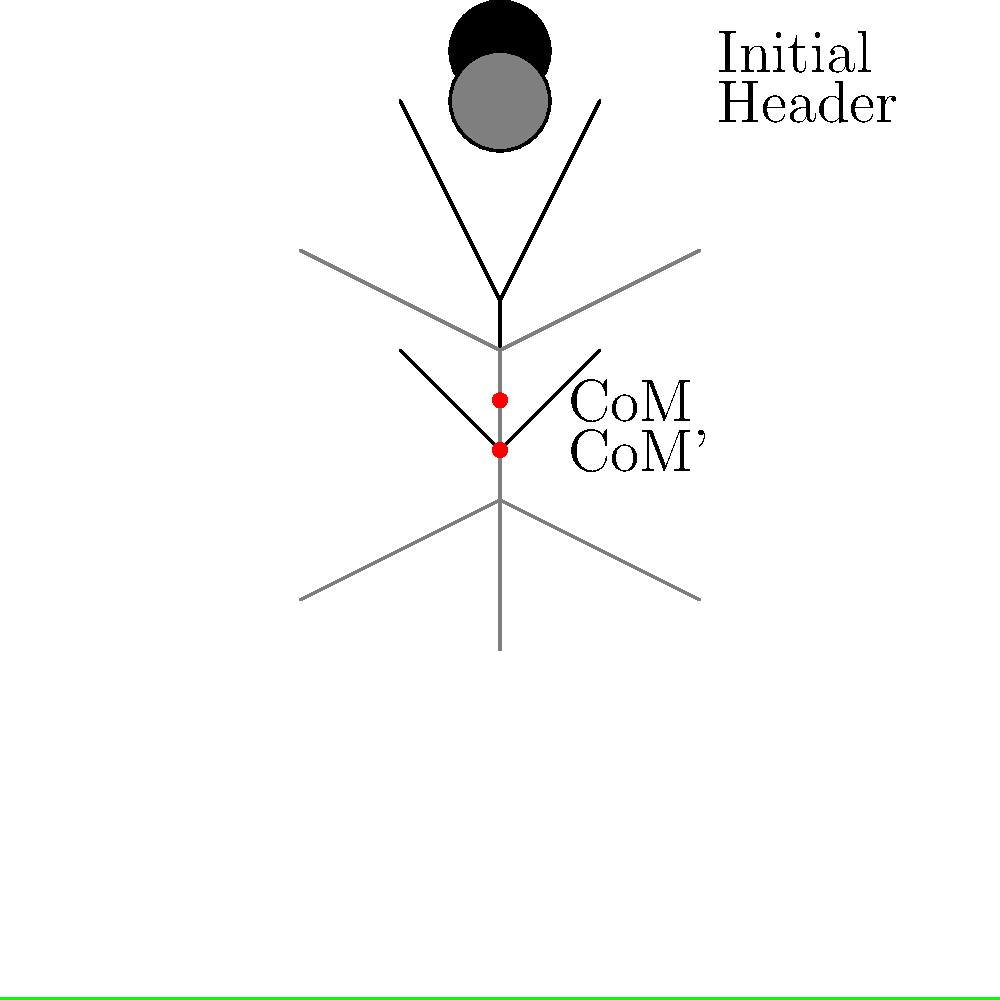During a soccer header, how does the center of mass (CoM) of a player typically shift, and what is the primary reason for this change? To understand the shift in the center of mass during a soccer header, let's break it down step-by-step:

1. Initial position: The player stands upright with their weight evenly distributed.

2. Header motion: As the player prepares to head the ball, they:
   a. Arch their back
   b. Extend their neck
   c. Shift their hips backward

3. CoM shift: These movements cause the center of mass to move:
   a. Downward: Due to the lowering of the upper body
   b. Slightly backward: Due to the arching of the back and shifting of the hips

4. Biomechanical reason: This shift in CoM is crucial because it:
   a. Increases the player's stability
   b. Generates more power for the header
   c. Allows for better control of the ball's direction

5. Physics principle: The shift in CoM creates a longer moment arm between the point of contact (head) and the CoM, increasing the torque generated during the header.

6. Return to initial position: After contact with the ball, the player returns to their original upright stance, bringing the CoM back to its initial position.

The primary reason for this CoM shift is to optimize the player's biomechanics for a more powerful and controlled header while maintaining balance.
Answer: The CoM shifts downward and slightly backward to increase stability, power, and control. 